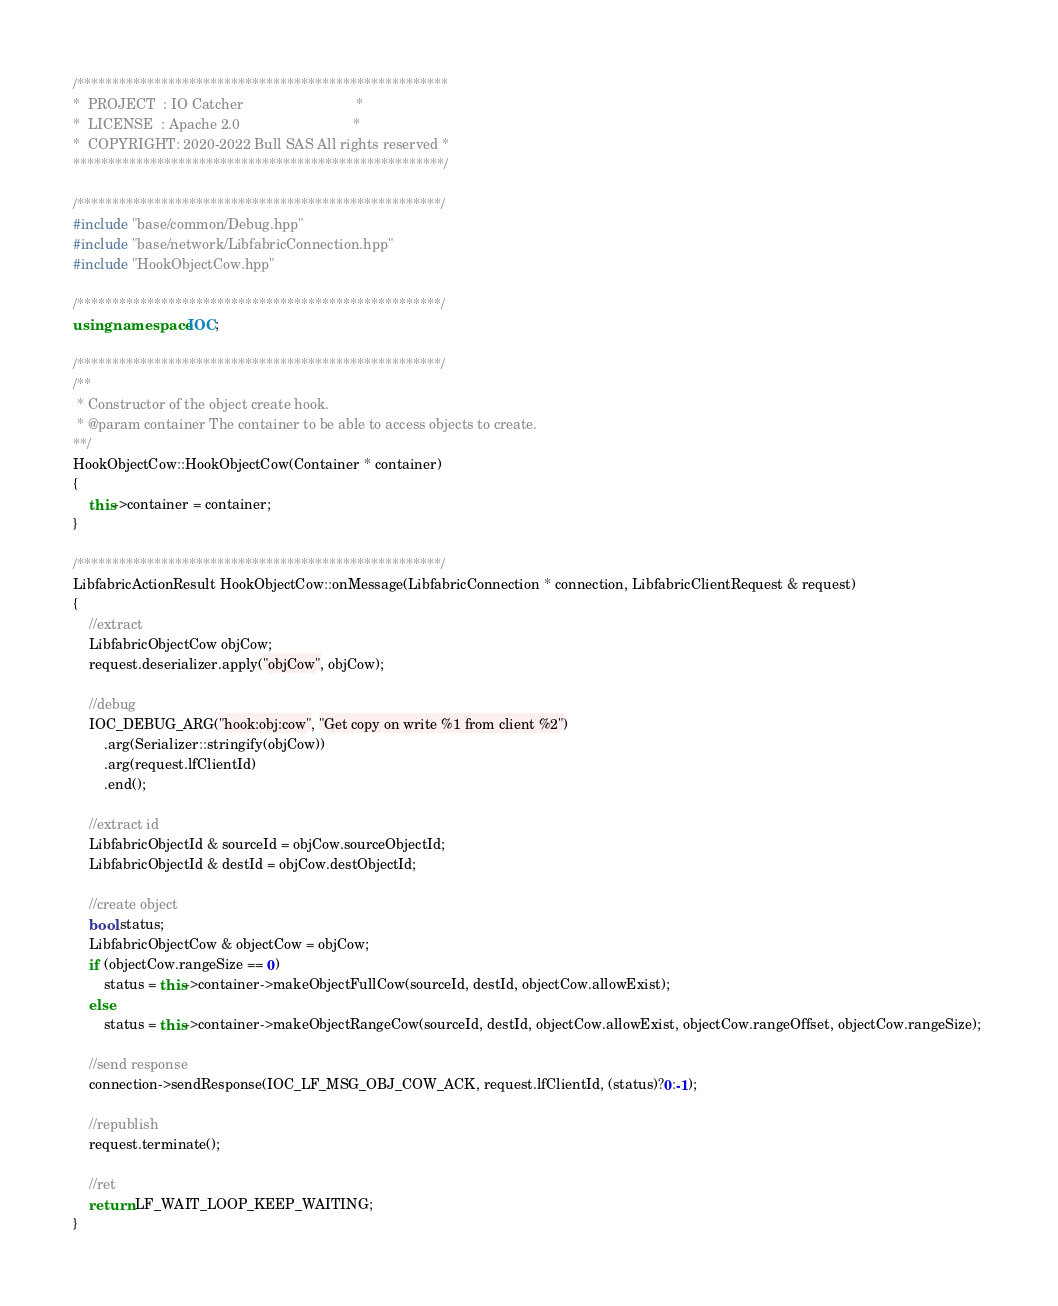Convert code to text. <code><loc_0><loc_0><loc_500><loc_500><_C++_>/*****************************************************
*  PROJECT  : IO Catcher                             *
*  LICENSE  : Apache 2.0                             *
*  COPYRIGHT: 2020-2022 Bull SAS All rights reserved *
*****************************************************/

/****************************************************/
#include "base/common/Debug.hpp"
#include "base/network/LibfabricConnection.hpp"
#include "HookObjectCow.hpp"

/****************************************************/
using namespace IOC;

/****************************************************/
/**
 * Constructor of the object create hook.
 * @param container The container to be able to access objects to create.
**/
HookObjectCow::HookObjectCow(Container * container)
{
	this->container = container;
}

/****************************************************/
LibfabricActionResult HookObjectCow::onMessage(LibfabricConnection * connection, LibfabricClientRequest & request)
{
	//extract
	LibfabricObjectCow objCow;
	request.deserializer.apply("objCow", objCow);

	//debug
	IOC_DEBUG_ARG("hook:obj:cow", "Get copy on write %1 from client %2")
		.arg(Serializer::stringify(objCow))
		.arg(request.lfClientId)
		.end();
	
	//extract id
	LibfabricObjectId & sourceId = objCow.sourceObjectId;
	LibfabricObjectId & destId = objCow.destObjectId;

	//create object
	bool status;
	LibfabricObjectCow & objectCow = objCow;
	if (objectCow.rangeSize == 0)
		status = this->container->makeObjectFullCow(sourceId, destId, objectCow.allowExist);
	else
		status = this->container->makeObjectRangeCow(sourceId, destId, objectCow.allowExist, objectCow.rangeOffset, objectCow.rangeSize); 

	//send response
	connection->sendResponse(IOC_LF_MSG_OBJ_COW_ACK, request.lfClientId, (status)?0:-1);

	//republish
	request.terminate();

	//ret
	return LF_WAIT_LOOP_KEEP_WAITING;
}
</code> 